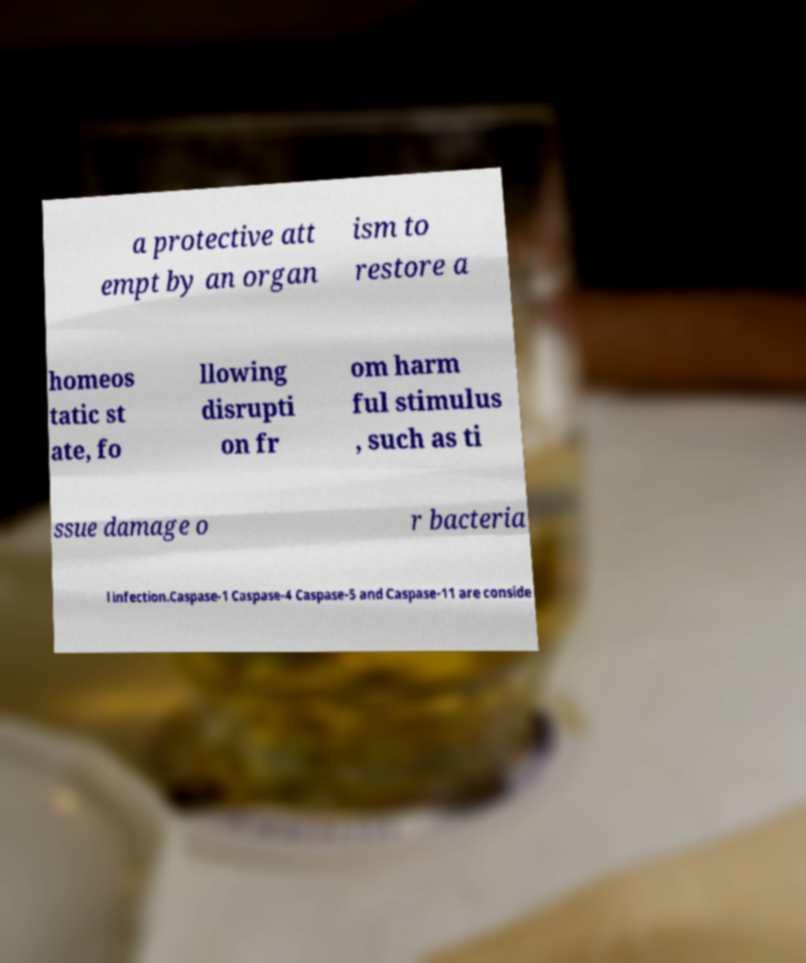There's text embedded in this image that I need extracted. Can you transcribe it verbatim? a protective att empt by an organ ism to restore a homeos tatic st ate, fo llowing disrupti on fr om harm ful stimulus , such as ti ssue damage o r bacteria l infection.Caspase-1 Caspase-4 Caspase-5 and Caspase-11 are conside 